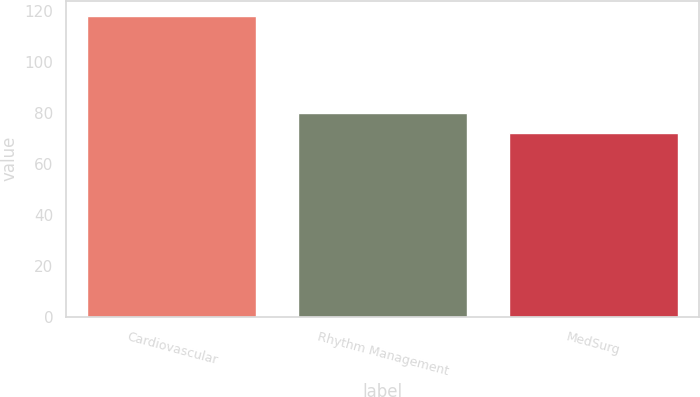<chart> <loc_0><loc_0><loc_500><loc_500><bar_chart><fcel>Cardiovascular<fcel>Rhythm Management<fcel>MedSurg<nl><fcel>118<fcel>80<fcel>72<nl></chart> 